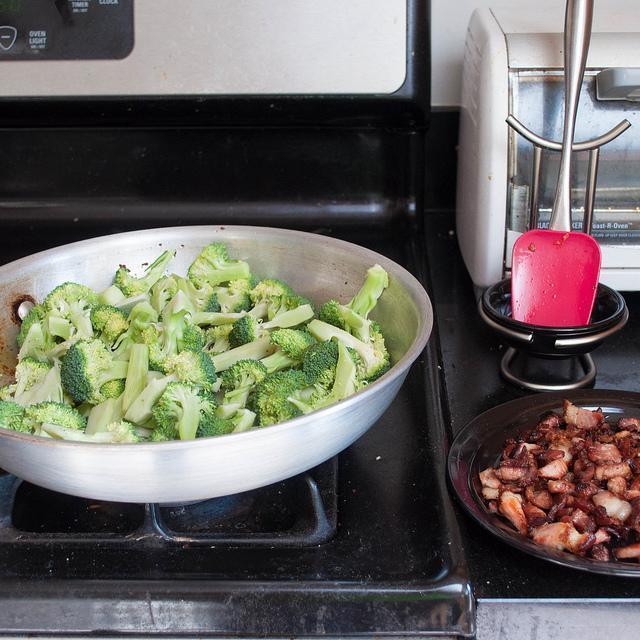How many bowls can you see?
Give a very brief answer. 2. How many elephants are there?
Give a very brief answer. 0. 